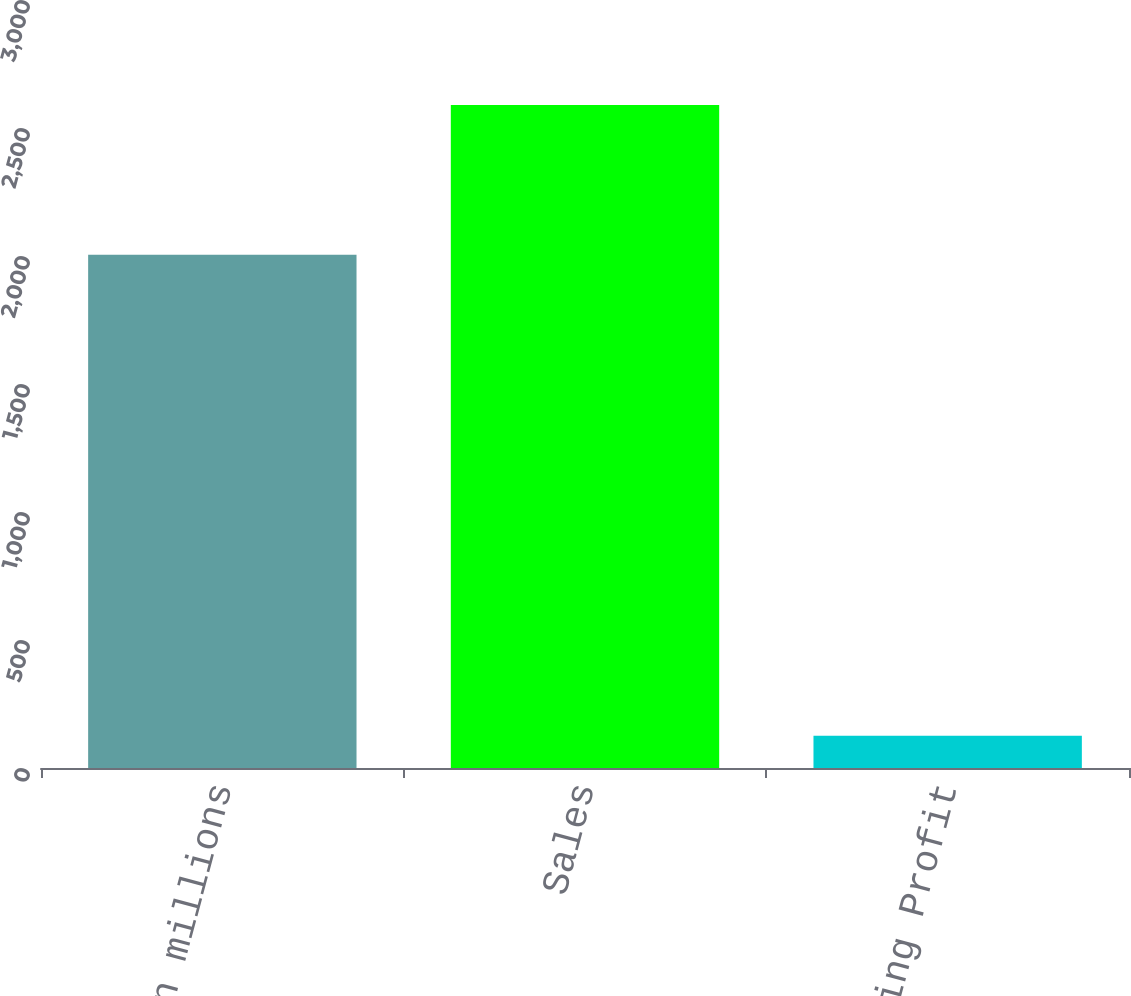Convert chart. <chart><loc_0><loc_0><loc_500><loc_500><bar_chart><fcel>In millions<fcel>Sales<fcel>Operating Profit<nl><fcel>2005<fcel>2590<fcel>126<nl></chart> 